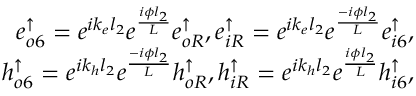Convert formula to latex. <formula><loc_0><loc_0><loc_500><loc_500>\begin{array} { r } { e _ { o 6 } ^ { \uparrow } = e ^ { i k _ { e } l _ { 2 } } e ^ { \frac { i \phi l _ { 2 } } { L } } e _ { o R } ^ { \uparrow } , e _ { i R } ^ { \uparrow } = e ^ { i k _ { e } l _ { 2 } } e ^ { \frac { - i \phi l _ { 2 } } { L } } e _ { i 6 } ^ { \uparrow } , } \\ { h _ { o 6 } ^ { \uparrow } = e ^ { i k _ { h } l _ { 2 } } e ^ { \frac { - i \phi l _ { 2 } } { L } } h _ { o R } ^ { \uparrow } , h _ { i R } ^ { \uparrow } = e ^ { i k _ { h } l _ { 2 } } e ^ { \frac { i \phi l _ { 2 } } { L } } h _ { i 6 } ^ { \uparrow } , } \end{array}</formula> 